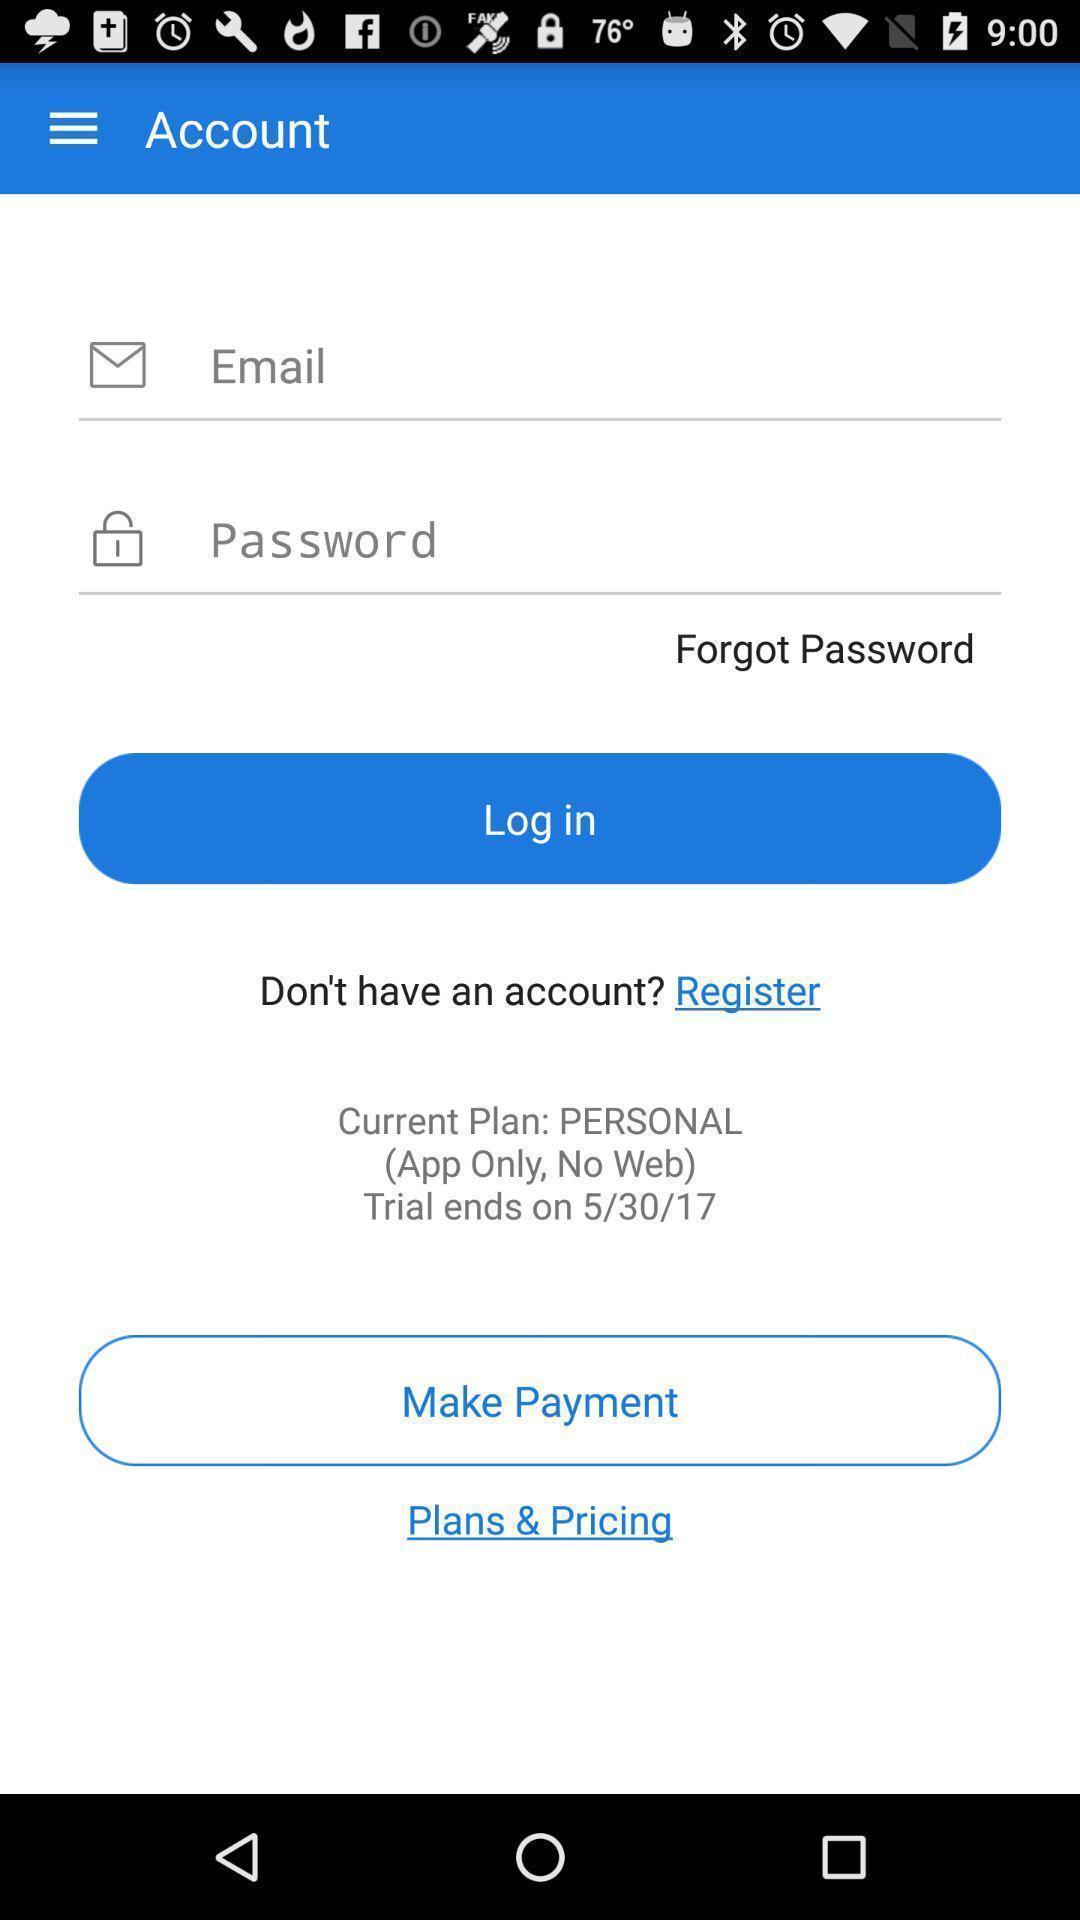Provide a detailed account of this screenshot. Page showing about login option. 